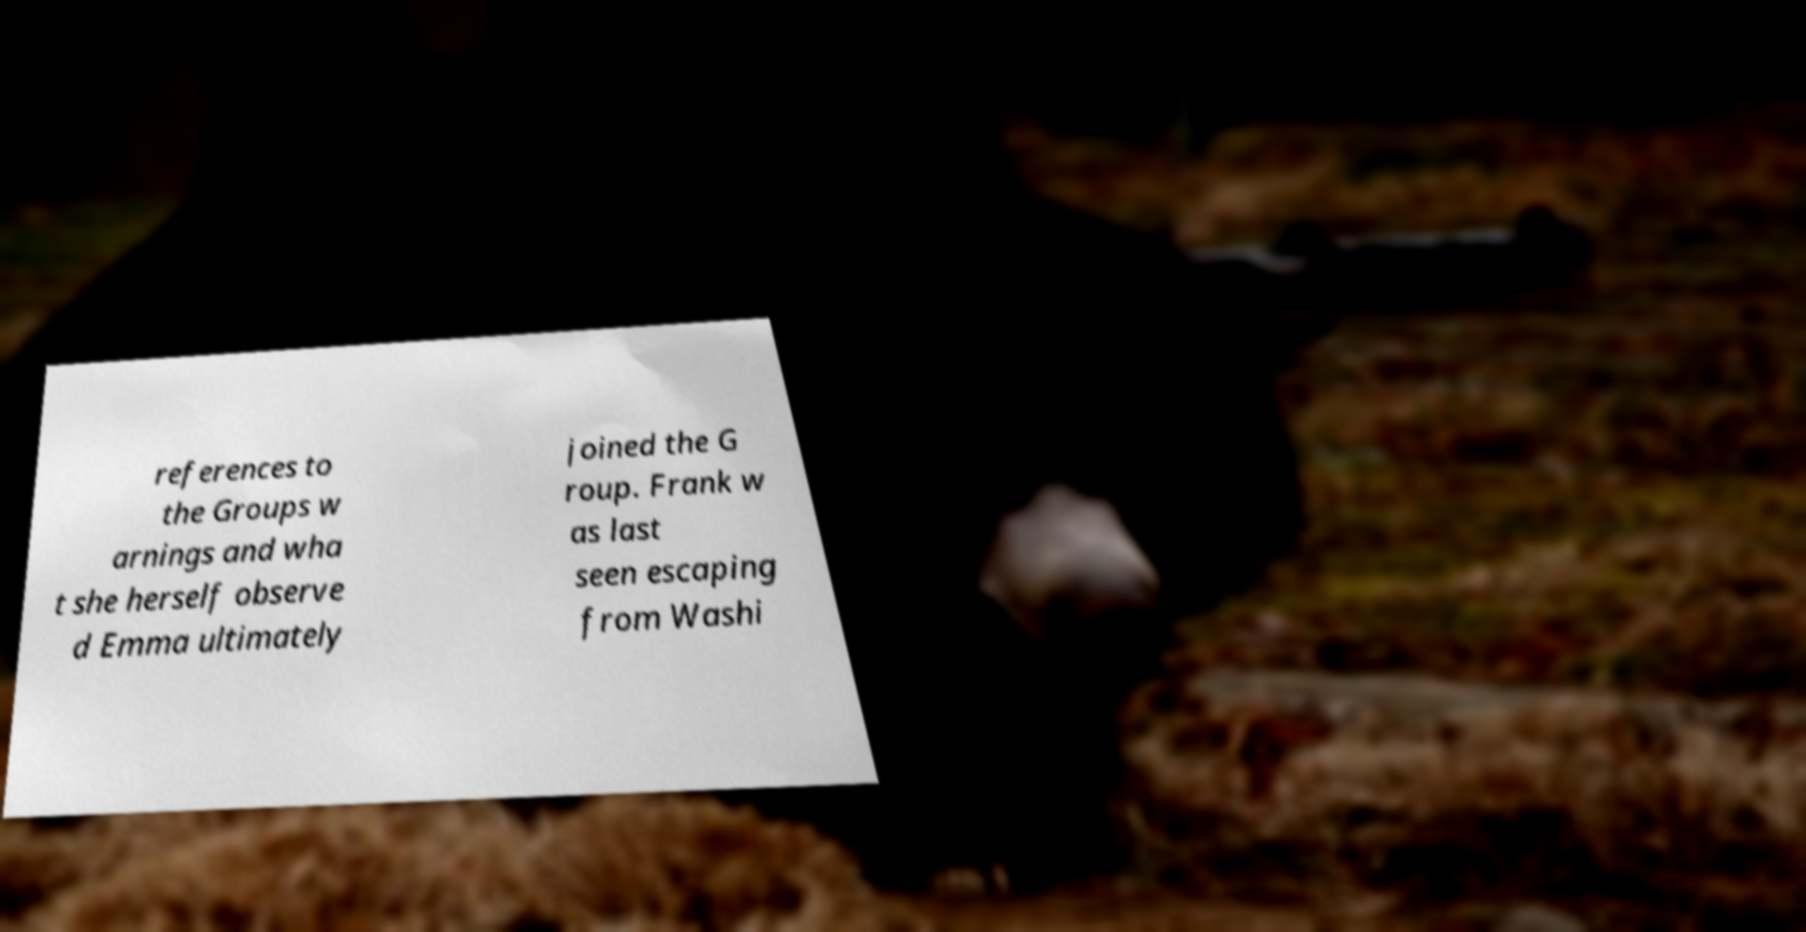I need the written content from this picture converted into text. Can you do that? references to the Groups w arnings and wha t she herself observe d Emma ultimately joined the G roup. Frank w as last seen escaping from Washi 